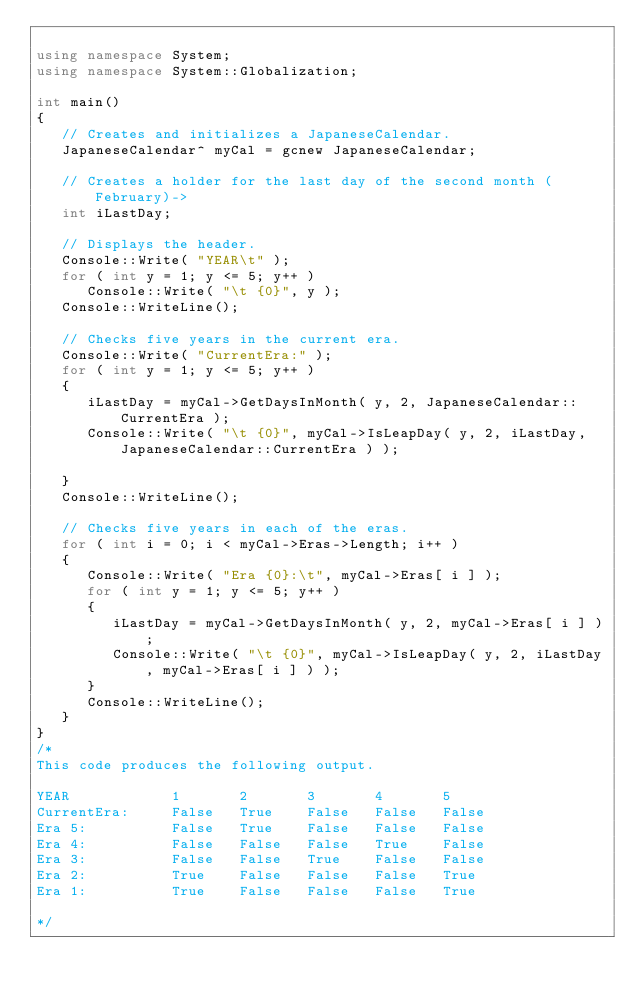Convert code to text. <code><loc_0><loc_0><loc_500><loc_500><_C++_>
using namespace System;
using namespace System::Globalization;

int main()
{
   // Creates and initializes a JapaneseCalendar.
   JapaneseCalendar^ myCal = gcnew JapaneseCalendar;
   
   // Creates a holder for the last day of the second month (February)->
   int iLastDay;
   
   // Displays the header.
   Console::Write( "YEAR\t" );
   for ( int y = 1; y <= 5; y++ )
      Console::Write( "\t {0}", y );
   Console::WriteLine();
   
   // Checks five years in the current era.
   Console::Write( "CurrentEra:" );
   for ( int y = 1; y <= 5; y++ )
   {
      iLastDay = myCal->GetDaysInMonth( y, 2, JapaneseCalendar::CurrentEra );
      Console::Write( "\t {0}", myCal->IsLeapDay( y, 2, iLastDay, JapaneseCalendar::CurrentEra ) );

   }
   Console::WriteLine();
   
   // Checks five years in each of the eras.
   for ( int i = 0; i < myCal->Eras->Length; i++ )
   {
      Console::Write( "Era {0}:\t", myCal->Eras[ i ] );
      for ( int y = 1; y <= 5; y++ )
      {
         iLastDay = myCal->GetDaysInMonth( y, 2, myCal->Eras[ i ] );
         Console::Write( "\t {0}", myCal->IsLeapDay( y, 2, iLastDay, myCal->Eras[ i ] ) );
      }
      Console::WriteLine();
   }
}
/*
This code produces the following output.

YEAR            1       2       3       4       5
CurrentEra:     False   True    False   False   False
Era 5:          False   True    False   False   False
Era 4:          False   False   False   True    False
Era 3:          False   False   True    False   False
Era 2:          True    False   False   False   True
Era 1:          True    False   False   False   True

*/
</code> 